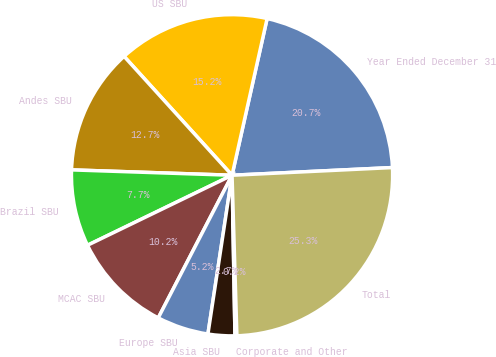Convert chart to OTSL. <chart><loc_0><loc_0><loc_500><loc_500><pie_chart><fcel>Year Ended December 31<fcel>US SBU<fcel>Andes SBU<fcel>Brazil SBU<fcel>MCAC SBU<fcel>Europe SBU<fcel>Asia SBU<fcel>Corporate and Other<fcel>Total<nl><fcel>20.73%<fcel>15.24%<fcel>12.73%<fcel>7.71%<fcel>10.22%<fcel>5.2%<fcel>2.69%<fcel>0.19%<fcel>25.28%<nl></chart> 